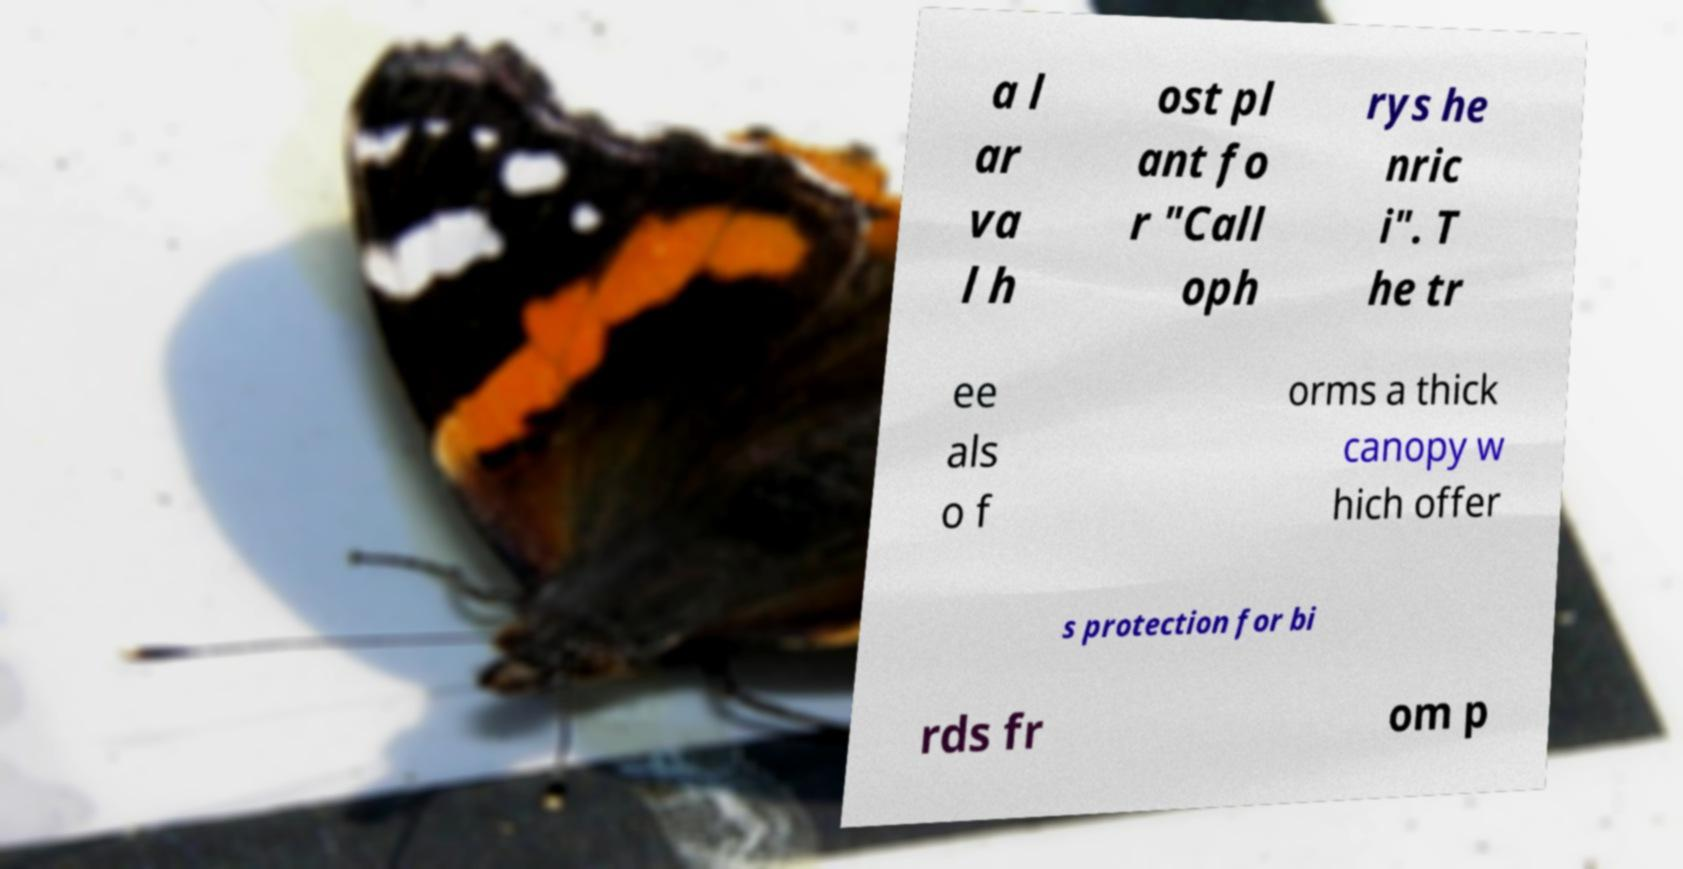Can you read and provide the text displayed in the image?This photo seems to have some interesting text. Can you extract and type it out for me? a l ar va l h ost pl ant fo r "Call oph rys he nric i". T he tr ee als o f orms a thick canopy w hich offer s protection for bi rds fr om p 